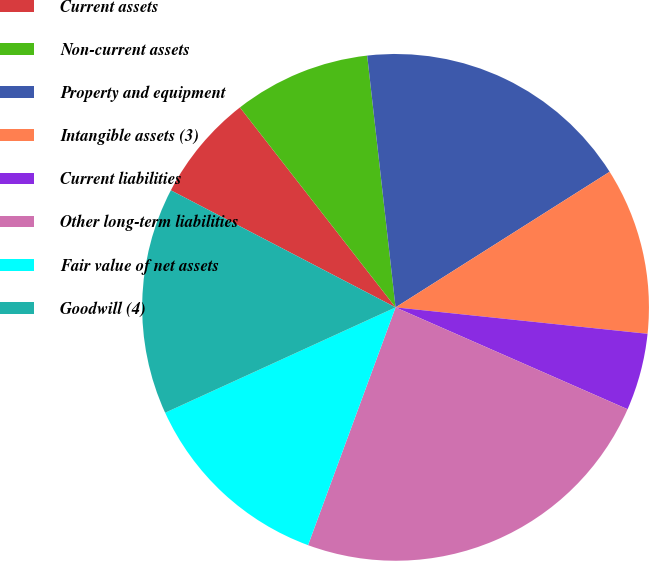<chart> <loc_0><loc_0><loc_500><loc_500><pie_chart><fcel>Current assets<fcel>Non-current assets<fcel>Property and equipment<fcel>Intangible assets (3)<fcel>Current liabilities<fcel>Other long-term liabilities<fcel>Fair value of net assets<fcel>Goodwill (4)<nl><fcel>6.83%<fcel>8.74%<fcel>17.8%<fcel>10.65%<fcel>4.92%<fcel>24.03%<fcel>12.56%<fcel>14.47%<nl></chart> 